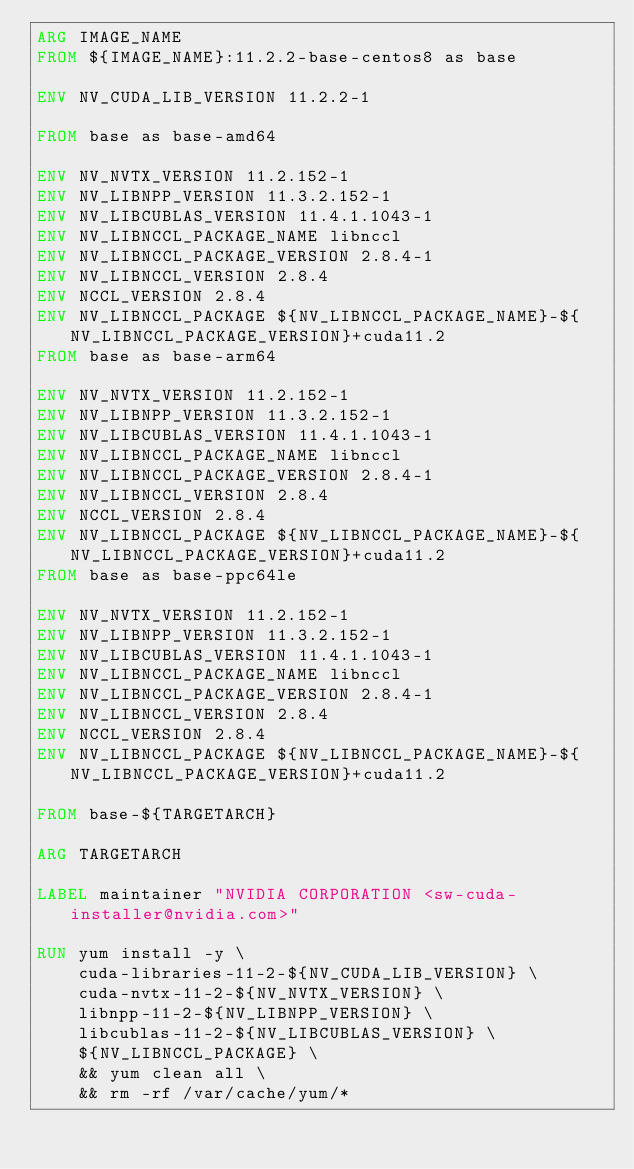<code> <loc_0><loc_0><loc_500><loc_500><_Dockerfile_>ARG IMAGE_NAME
FROM ${IMAGE_NAME}:11.2.2-base-centos8 as base

ENV NV_CUDA_LIB_VERSION 11.2.2-1

FROM base as base-amd64

ENV NV_NVTX_VERSION 11.2.152-1
ENV NV_LIBNPP_VERSION 11.3.2.152-1
ENV NV_LIBCUBLAS_VERSION 11.4.1.1043-1
ENV NV_LIBNCCL_PACKAGE_NAME libnccl
ENV NV_LIBNCCL_PACKAGE_VERSION 2.8.4-1
ENV NV_LIBNCCL_VERSION 2.8.4
ENV NCCL_VERSION 2.8.4
ENV NV_LIBNCCL_PACKAGE ${NV_LIBNCCL_PACKAGE_NAME}-${NV_LIBNCCL_PACKAGE_VERSION}+cuda11.2
FROM base as base-arm64

ENV NV_NVTX_VERSION 11.2.152-1
ENV NV_LIBNPP_VERSION 11.3.2.152-1
ENV NV_LIBCUBLAS_VERSION 11.4.1.1043-1
ENV NV_LIBNCCL_PACKAGE_NAME libnccl
ENV NV_LIBNCCL_PACKAGE_VERSION 2.8.4-1
ENV NV_LIBNCCL_VERSION 2.8.4
ENV NCCL_VERSION 2.8.4
ENV NV_LIBNCCL_PACKAGE ${NV_LIBNCCL_PACKAGE_NAME}-${NV_LIBNCCL_PACKAGE_VERSION}+cuda11.2
FROM base as base-ppc64le

ENV NV_NVTX_VERSION 11.2.152-1
ENV NV_LIBNPP_VERSION 11.3.2.152-1
ENV NV_LIBCUBLAS_VERSION 11.4.1.1043-1
ENV NV_LIBNCCL_PACKAGE_NAME libnccl
ENV NV_LIBNCCL_PACKAGE_VERSION 2.8.4-1
ENV NV_LIBNCCL_VERSION 2.8.4
ENV NCCL_VERSION 2.8.4
ENV NV_LIBNCCL_PACKAGE ${NV_LIBNCCL_PACKAGE_NAME}-${NV_LIBNCCL_PACKAGE_VERSION}+cuda11.2

FROM base-${TARGETARCH}

ARG TARGETARCH

LABEL maintainer "NVIDIA CORPORATION <sw-cuda-installer@nvidia.com>"

RUN yum install -y \
    cuda-libraries-11-2-${NV_CUDA_LIB_VERSION} \
    cuda-nvtx-11-2-${NV_NVTX_VERSION} \
    libnpp-11-2-${NV_LIBNPP_VERSION} \
    libcublas-11-2-${NV_LIBCUBLAS_VERSION} \
    ${NV_LIBNCCL_PACKAGE} \
    && yum clean all \
    && rm -rf /var/cache/yum/*</code> 